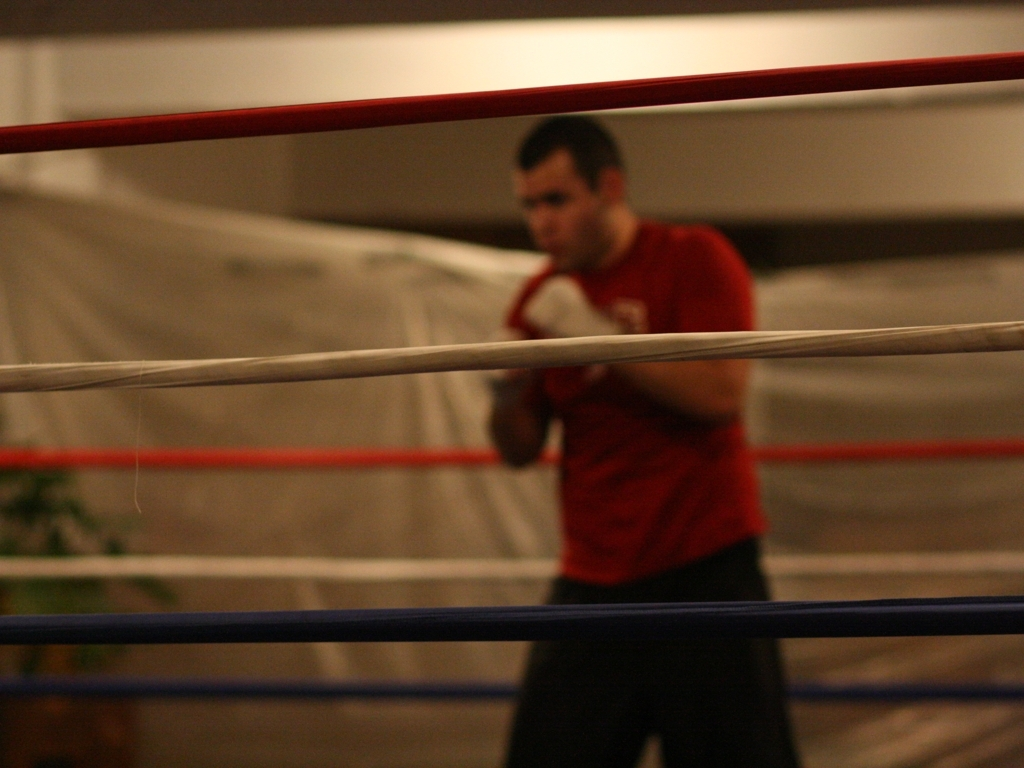Are the features sharp? The features of the subject are not sharp due to the shallow depth of field and motion blur. It appears that the camera focused on the foreground, rendering the person in the background slightly out of focus and thus, not sharp. 